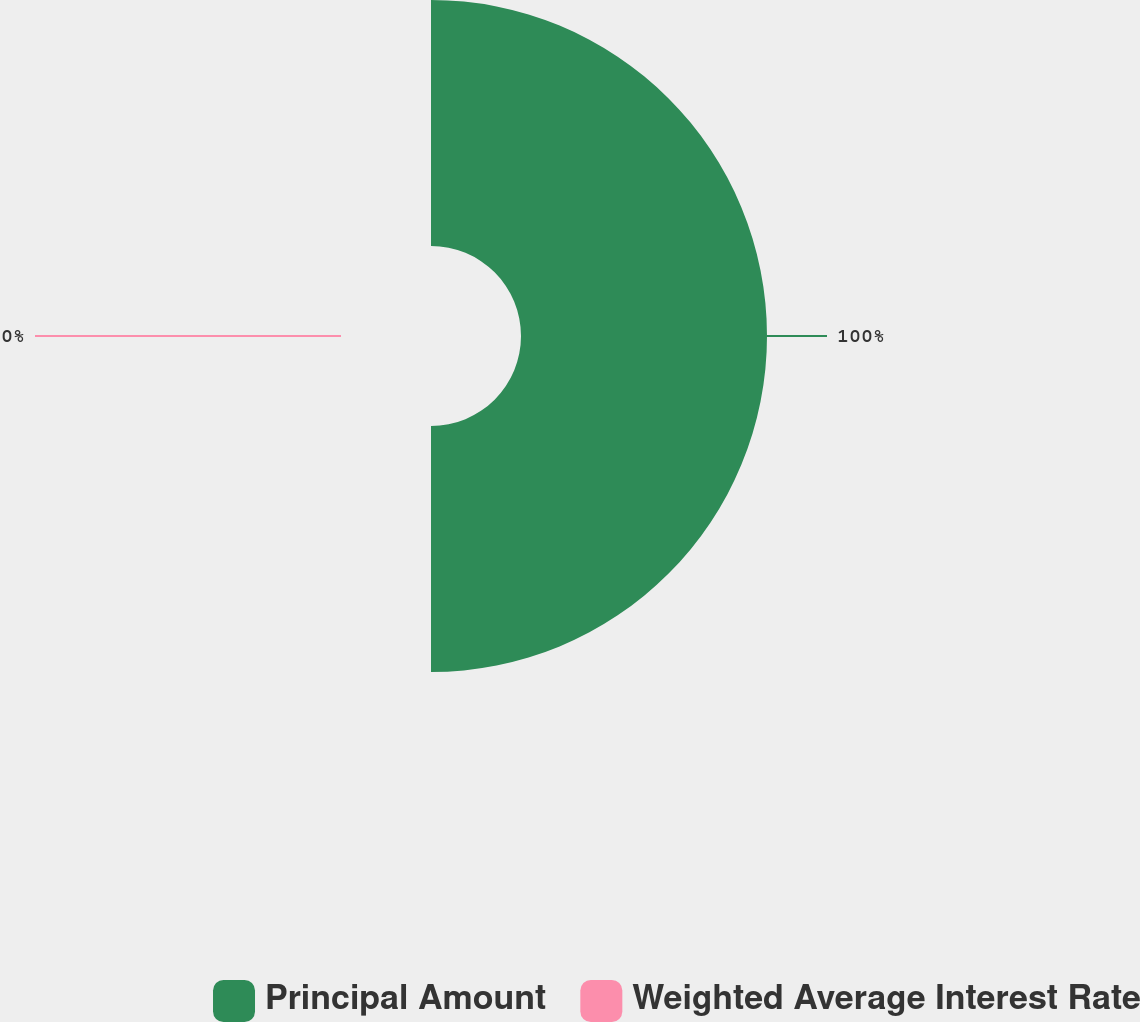<chart> <loc_0><loc_0><loc_500><loc_500><pie_chart><fcel>Principal Amount<fcel>Weighted Average Interest Rate<nl><fcel>100.0%<fcel>0.0%<nl></chart> 